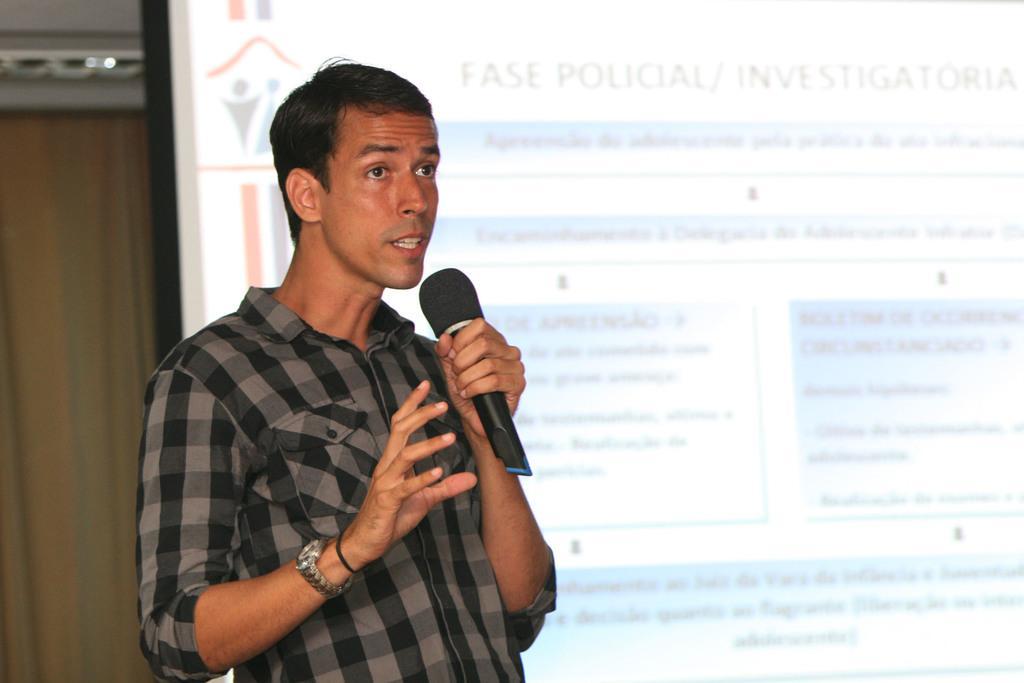Can you describe this image briefly? In this picture I can see there is a standing and he is wearing a shirt and he is holding a microphone in his left hand and in the backdrop there is a screen. 